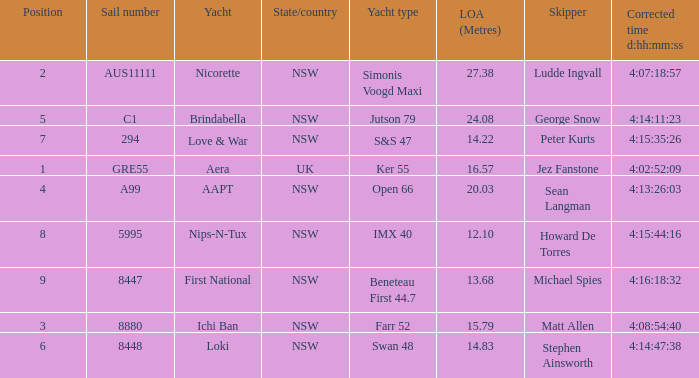What is the overall length of sail for the boat with a correct time of 4:15:35:26? 14.22. 